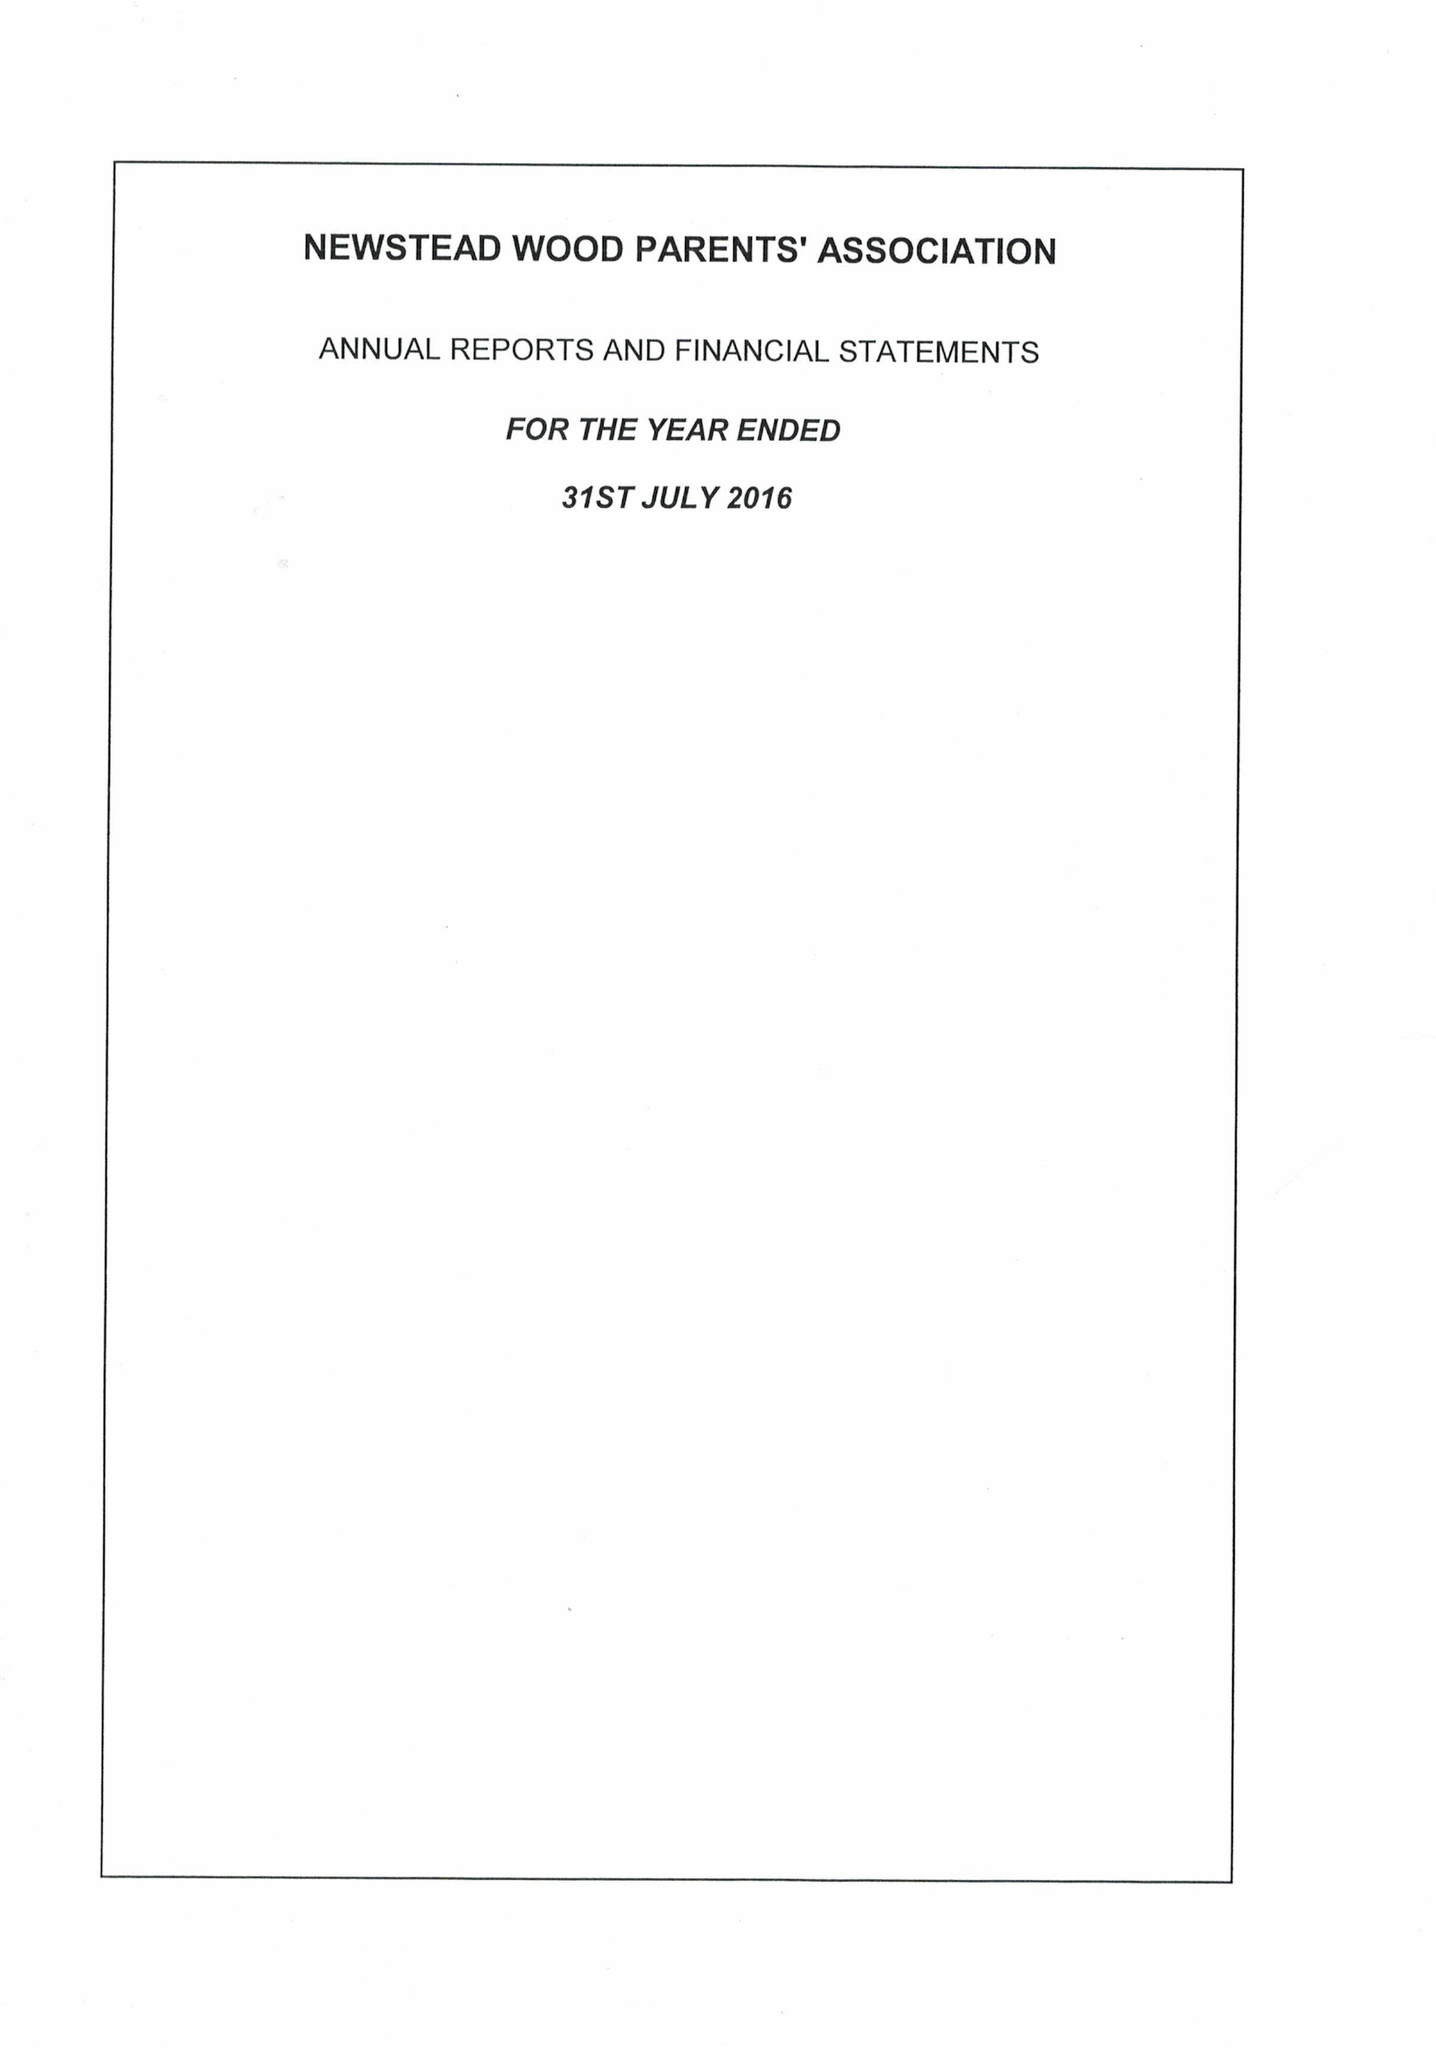What is the value for the report_date?
Answer the question using a single word or phrase. 2016-07-31 